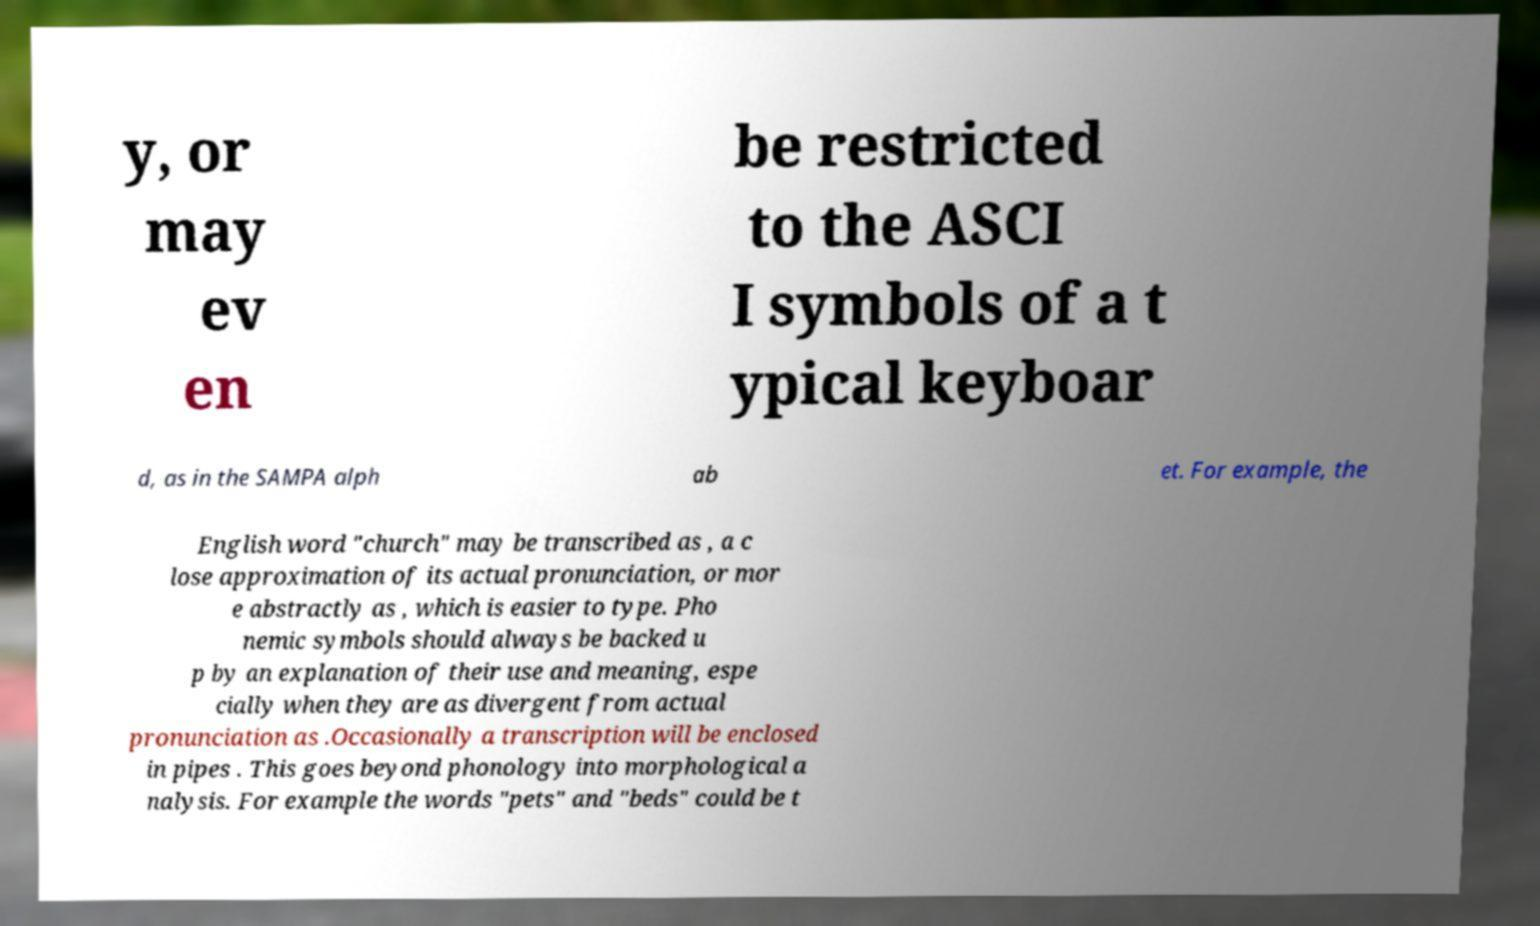For documentation purposes, I need the text within this image transcribed. Could you provide that? y, or may ev en be restricted to the ASCI I symbols of a t ypical keyboar d, as in the SAMPA alph ab et. For example, the English word "church" may be transcribed as , a c lose approximation of its actual pronunciation, or mor e abstractly as , which is easier to type. Pho nemic symbols should always be backed u p by an explanation of their use and meaning, espe cially when they are as divergent from actual pronunciation as .Occasionally a transcription will be enclosed in pipes . This goes beyond phonology into morphological a nalysis. For example the words "pets" and "beds" could be t 